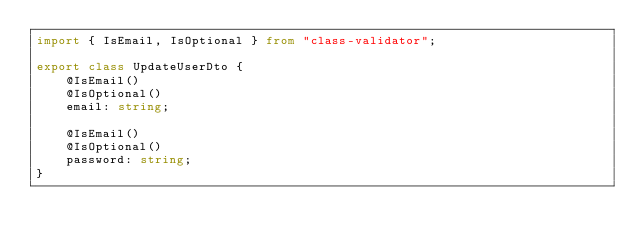<code> <loc_0><loc_0><loc_500><loc_500><_TypeScript_>import { IsEmail, IsOptional } from "class-validator";

export class UpdateUserDto {
    @IsEmail()
    @IsOptional()
    email: string;

    @IsEmail()
    @IsOptional()
    password: string;
}</code> 